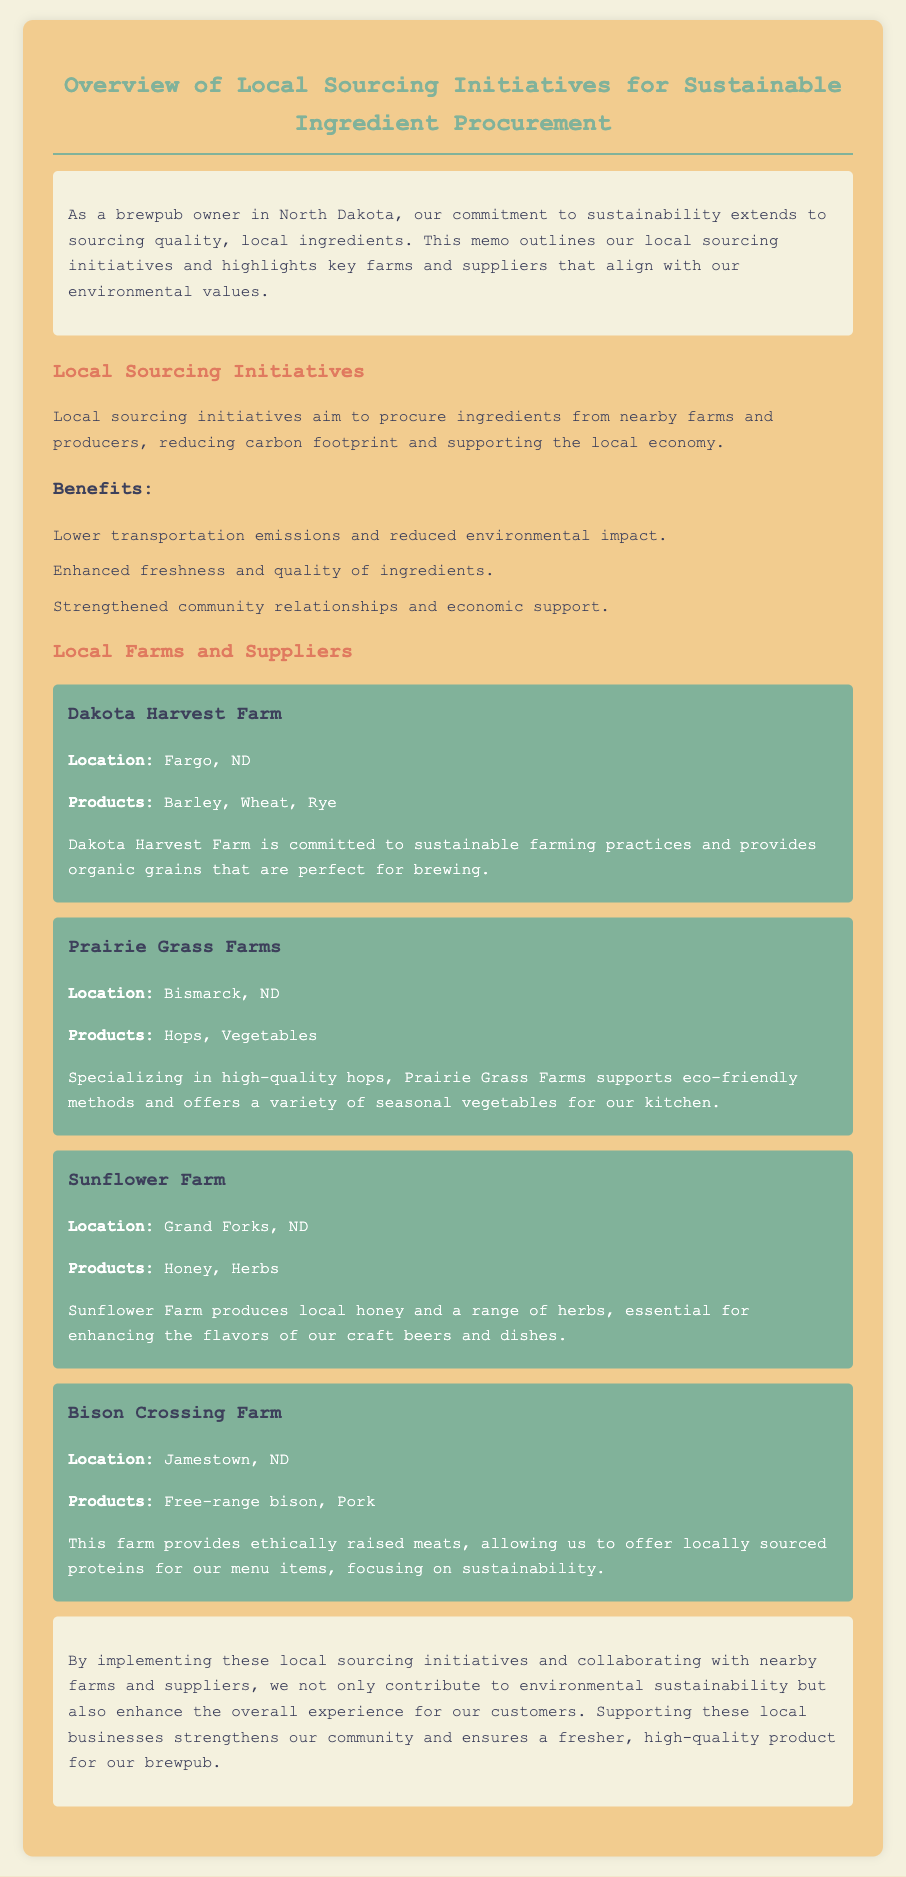What is the title of the memo? The title of the memo is found in the header, stating the subject of the correspondence clearly.
Answer: Overview of Local Sourcing Initiatives for Sustainable Ingredient Procurement Which farm is located in Fargo, ND? The document contains specific information about the location of each supplier, allowing for easy identification.
Answer: Dakota Harvest Farm What products does Prairie Grass Farms provide? The products offered by each farm are listed to showcase their contributions, providing insights into ingredient sourcing.
Answer: Hops, Vegetables What is one benefit of local sourcing initiatives mentioned in the memo? The memo highlights several advantages of local sourcing, which directly relate to sustainability and quality.
Answer: Lower transportation emissions Which supplier provides honey? The document specifies the products each supplier offers, enabling specific queries about goods produced.
Answer: Sunflower Farm How many farms and suppliers are listed in the document? The total number of suppliers is relevant for understanding the collaborative efforts made towards sustainability.
Answer: Four 